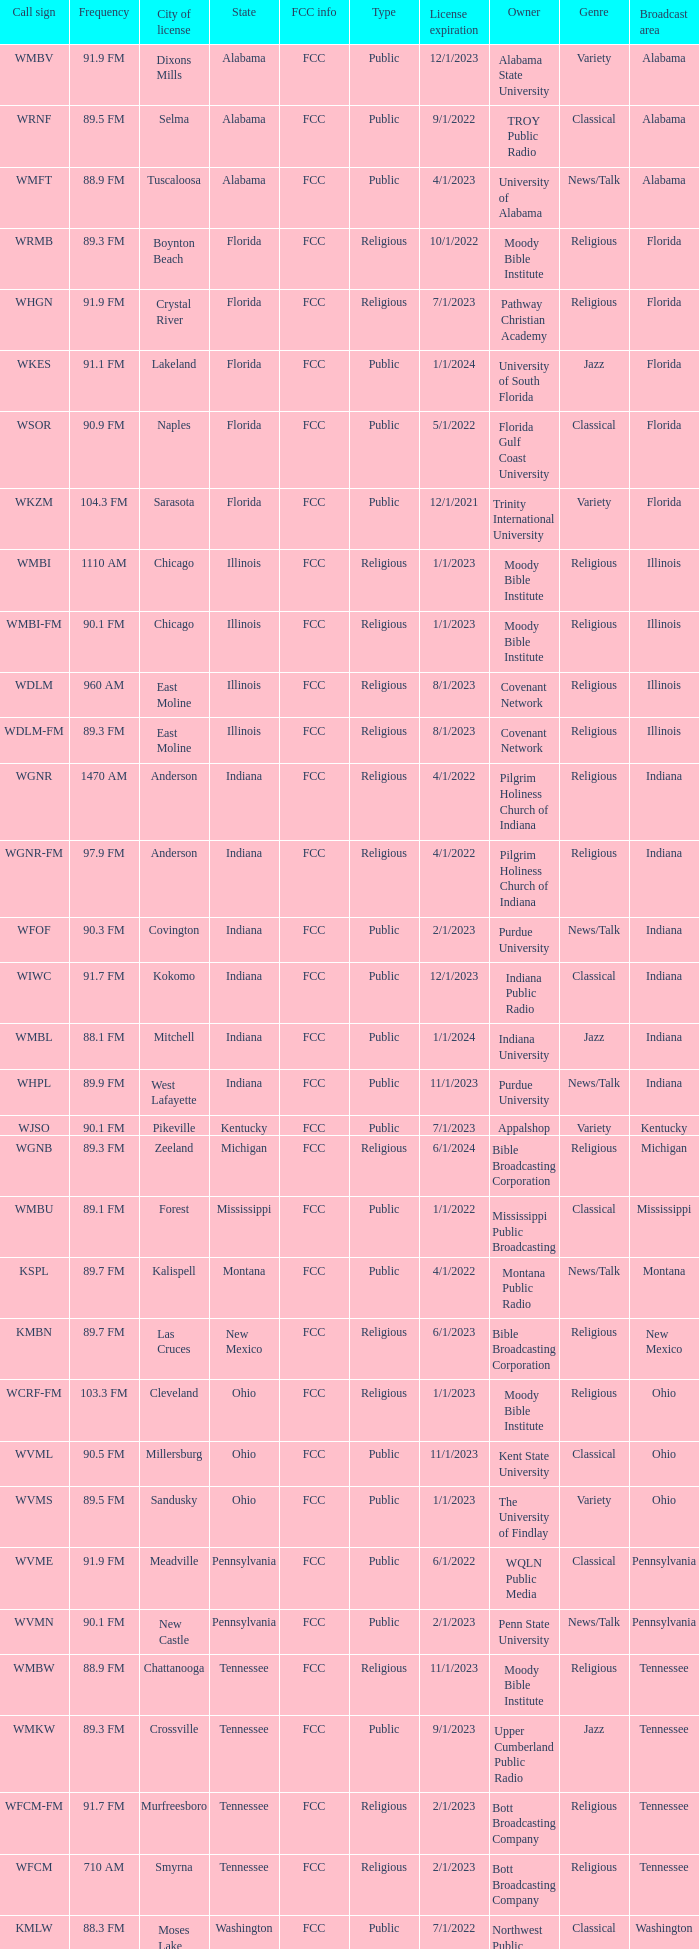What is the frequency of the radio station in Indiana that has a call sign of WGNR? 1470 AM. 